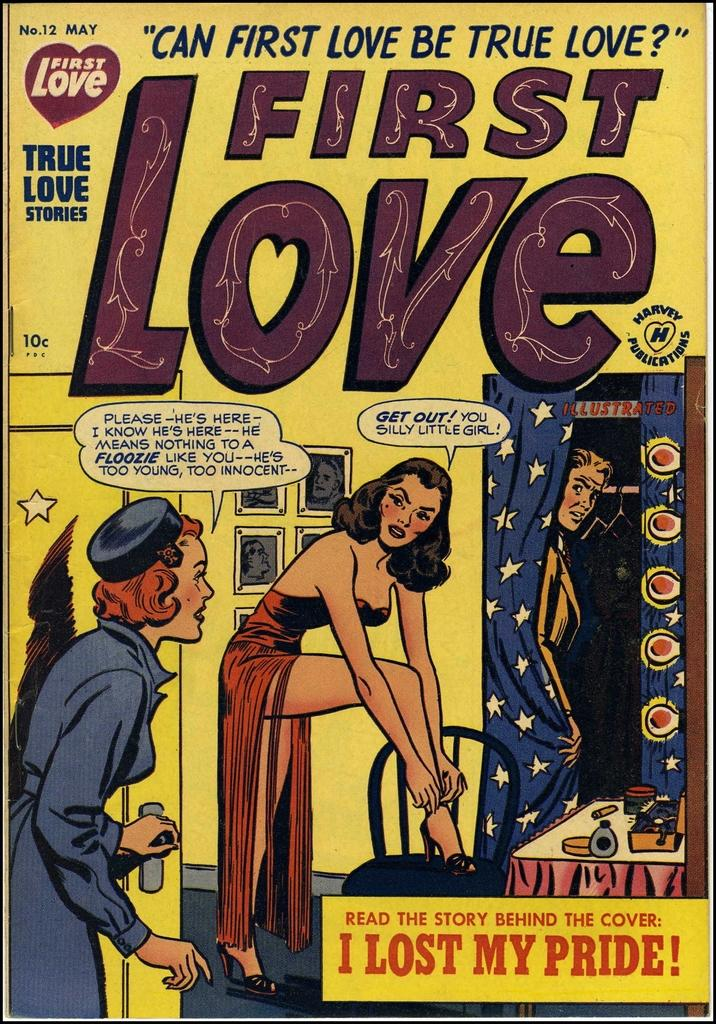<image>
Present a compact description of the photo's key features. a magazine that says 'can first love be true love?' on the top 